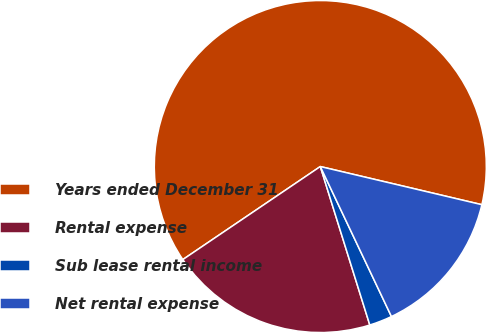Convert chart to OTSL. <chart><loc_0><loc_0><loc_500><loc_500><pie_chart><fcel>Years ended December 31<fcel>Rental expense<fcel>Sub lease rental income<fcel>Net rental expense<nl><fcel>63.16%<fcel>20.35%<fcel>2.23%<fcel>14.26%<nl></chart> 